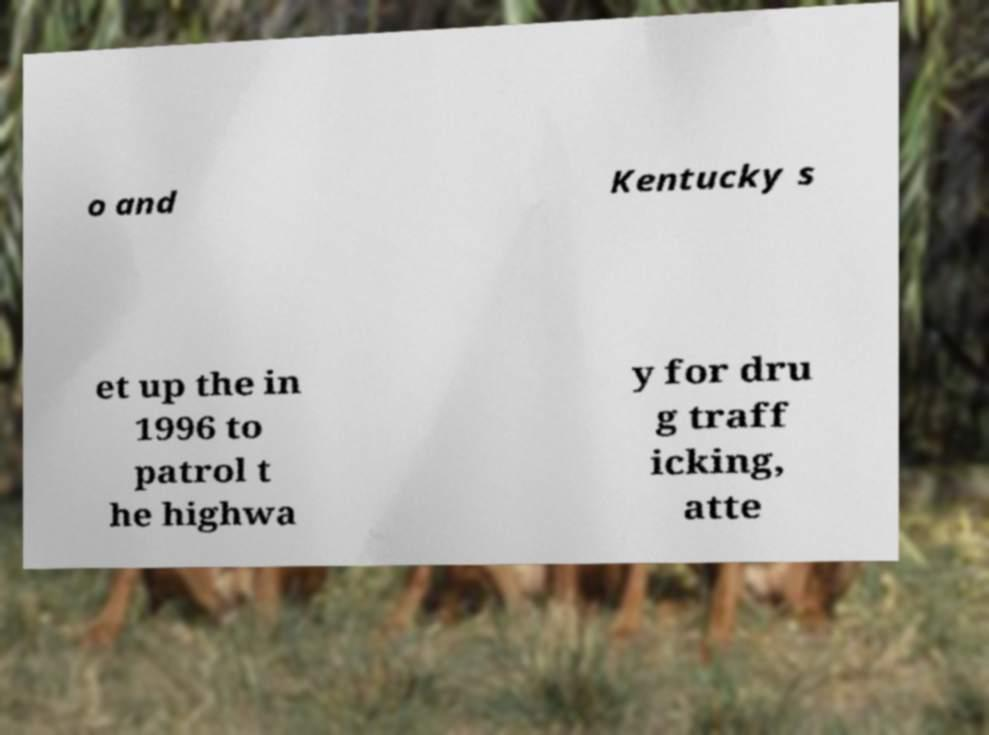For documentation purposes, I need the text within this image transcribed. Could you provide that? o and Kentucky s et up the in 1996 to patrol t he highwa y for dru g traff icking, atte 